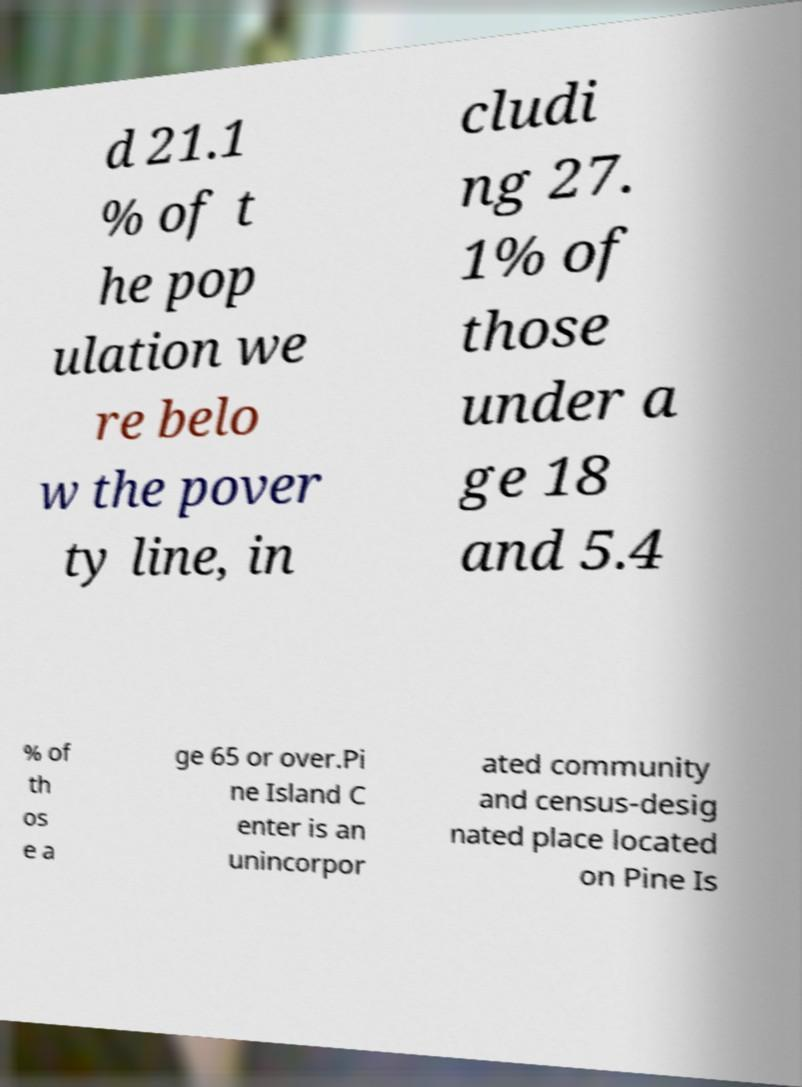Please identify and transcribe the text found in this image. d 21.1 % of t he pop ulation we re belo w the pover ty line, in cludi ng 27. 1% of those under a ge 18 and 5.4 % of th os e a ge 65 or over.Pi ne Island C enter is an unincorpor ated community and census-desig nated place located on Pine Is 